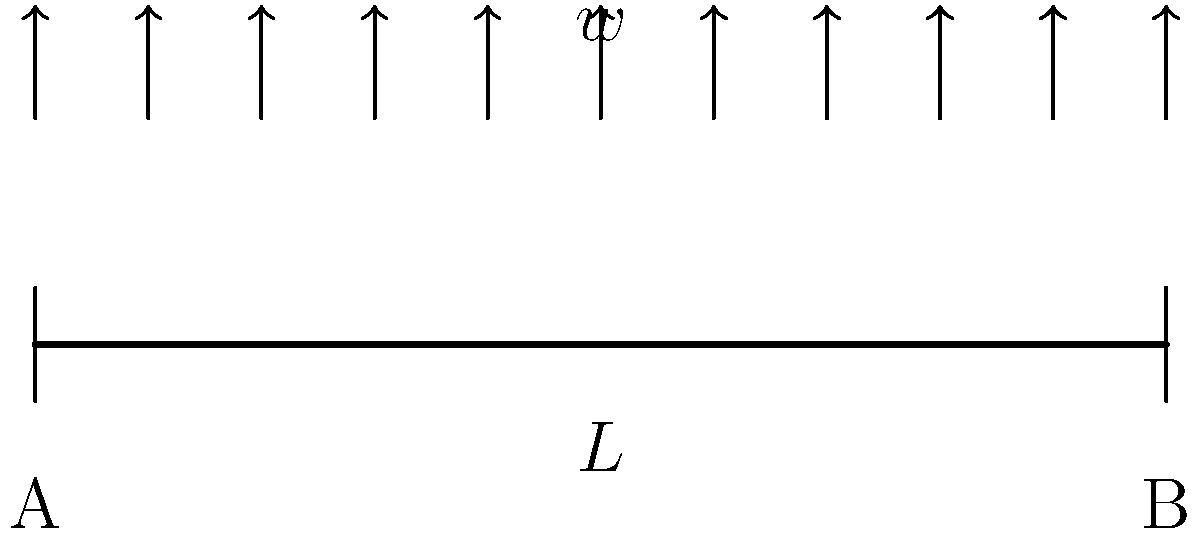A simply supported beam of length $L$ is subjected to a uniformly distributed load $w$ per unit length. What is the maximum bending moment experienced by the beam, and at which point along the beam does it occur? To find the maximum bending moment for a simply supported beam with a uniformly distributed load, we can follow these steps:

1) First, we need to calculate the reaction forces at the supports. Due to symmetry, both reaction forces will be equal:

   $$R_A = R_B = \frac{wL}{2}$$

2) The bending moment at any point $x$ along the beam is given by:

   $$M(x) = R_A x - \frac{wx^2}{2}$$

3) To find the maximum bending moment, we need to find where the derivative of $M(x)$ with respect to $x$ is zero:

   $$\frac{dM}{dx} = R_A - wx = 0$$

4) Solving this equation:

   $$\frac{wL}{2} - wx = 0$$
   $$x = \frac{L}{2}$$

5) This confirms that the maximum bending moment occurs at the middle of the beam.

6) To find the value of the maximum bending moment, we substitute $x = \frac{L}{2}$ into the bending moment equation:

   $$M_{max} = \frac{wL}{2} \cdot \frac{L}{2} - \frac{w(\frac{L}{2})^2}{2}$$
   $$M_{max} = \frac{wL^2}{4} - \frac{wL^2}{8} = \frac{wL^2}{8}$$

Therefore, the maximum bending moment is $\frac{wL^2}{8}$ and it occurs at the midpoint of the beam.
Answer: $\frac{wL^2}{8}$ at $\frac{L}{2}$ 